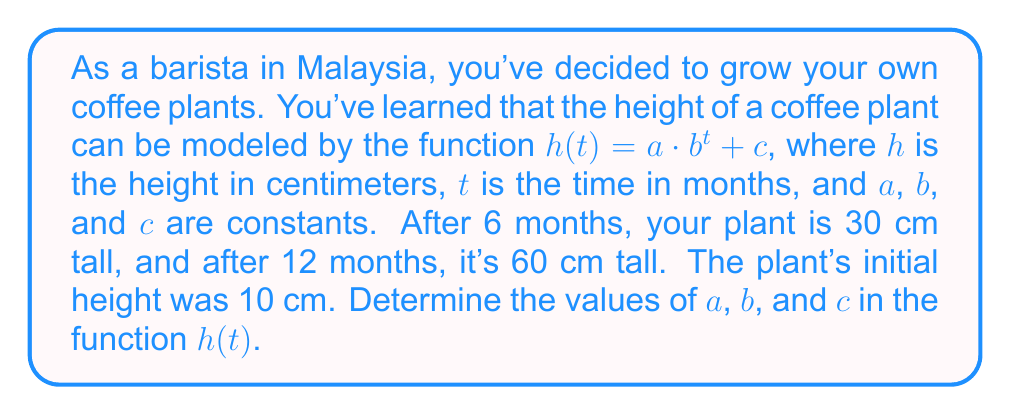Solve this math problem. Let's approach this step-by-step:

1) We know that the initial height is 10 cm, so $c = 10$.

2) We can now write our function as $h(t) = a \cdot b^t + 10$.

3) We have two more pieces of information:
   After 6 months: $h(6) = 30$
   After 12 months: $h(12) = 60$

4) Let's use these to create two equations:

   $30 = a \cdot b^6 + 10$
   $60 = a \cdot b^{12} + 10$

5) Subtracting 10 from both sides in each equation:

   $20 = a \cdot b^6$
   $50 = a \cdot b^{12}$

6) Dividing the second equation by the first:

   $\frac{50}{20} = \frac{a \cdot b^{12}}{a \cdot b^6}$

7) Simplifying:

   $\frac{5}{2} = b^6$

8) Taking the 6th root of both sides:

   $b = \sqrt[6]{\frac{5}{2}} \approx 1.1447$

9) Now that we know $b$, we can find $a$ using either of the equations from step 5. Let's use the first one:

   $20 = a \cdot (1.1447)^6$
   $20 = a \cdot 2.25$
   $a = \frac{20}{2.25} \approx 8.8889$

10) Therefore, our function is:

    $h(t) \approx 8.8889 \cdot 1.1447^t + 10$
Answer: $a \approx 8.8889$, $b \approx 1.1447$, $c = 10$ 